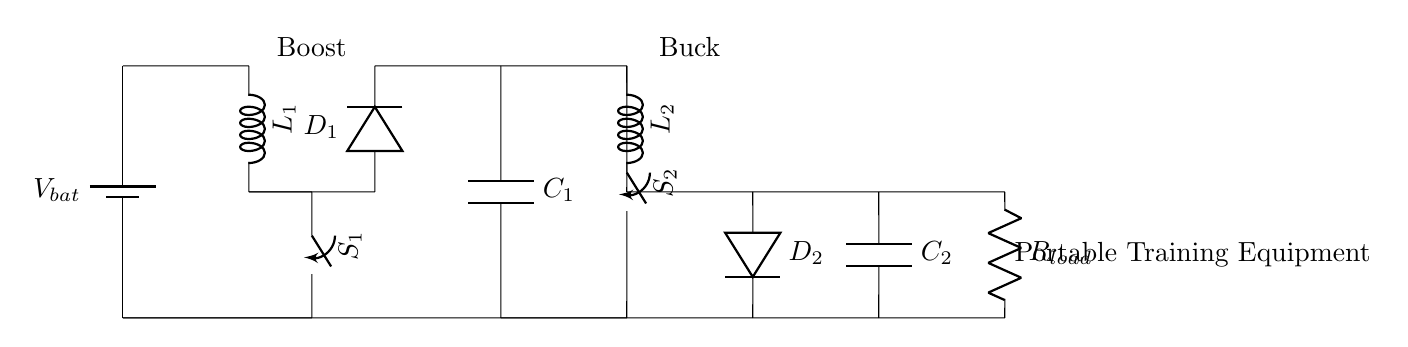What is the main source of power in this circuit? The main source of power is the battery labeled V_bat, which provides the necessary voltage for the circuit to function.
Answer: battery What type of converter is used to step up the voltage? The voltage is stepped up by the boost converter, indicated by the inductor L_1 and associated components S_1, D_1, and C_1. These components work together to increase the voltage from the battery.
Answer: Boost converter What component limits the current to the load? The resistor labeled R_load is responsible for limiting the current to the load in this circuit. It provides resistance that affects the amount of current flowing through the circuit.
Answer: Resistor Which component stores energy in the boost section? The capacitor labeled C_1 stores energy in the boost section of the circuit. It charges and discharges to help maintain the output voltage as needed.
Answer: Capacitor What is the role of the switch S_2? The switch S_2 controls the connection in the buck converter, allowing or interrupting the flow of electricity to adjust the output voltage delivered to the load.
Answer: Controls connection Explain how the buck converter affects the output voltage. The buck converter reduces the voltage supplied to the load by using the inductor L_2, switching S_2, diode D_2, and capacitor C_2. It converts higher voltage down to a lower voltage suitable for the portable equipment by controlling the energy transfer based on the duty cycle of the switch. By smoothing the current with the capacitor, it ensures that the load receives a stable and lower voltage.
Answer: Reduces voltage 